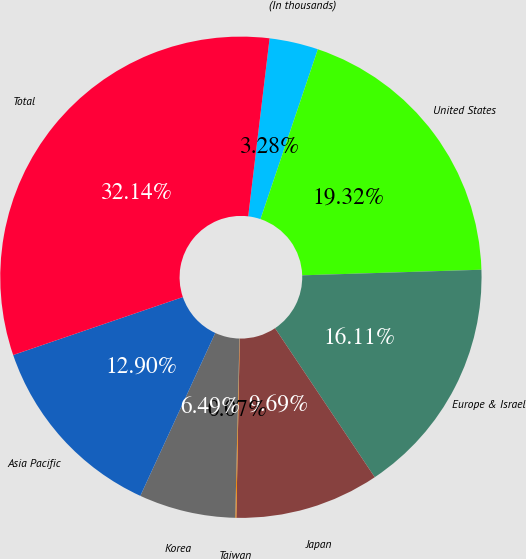Convert chart to OTSL. <chart><loc_0><loc_0><loc_500><loc_500><pie_chart><fcel>(In thousands)<fcel>United States<fcel>Europe & Israel<fcel>Japan<fcel>Taiwan<fcel>Korea<fcel>Asia Pacific<fcel>Total<nl><fcel>3.28%<fcel>19.32%<fcel>16.11%<fcel>9.69%<fcel>0.07%<fcel>6.49%<fcel>12.9%<fcel>32.14%<nl></chart> 